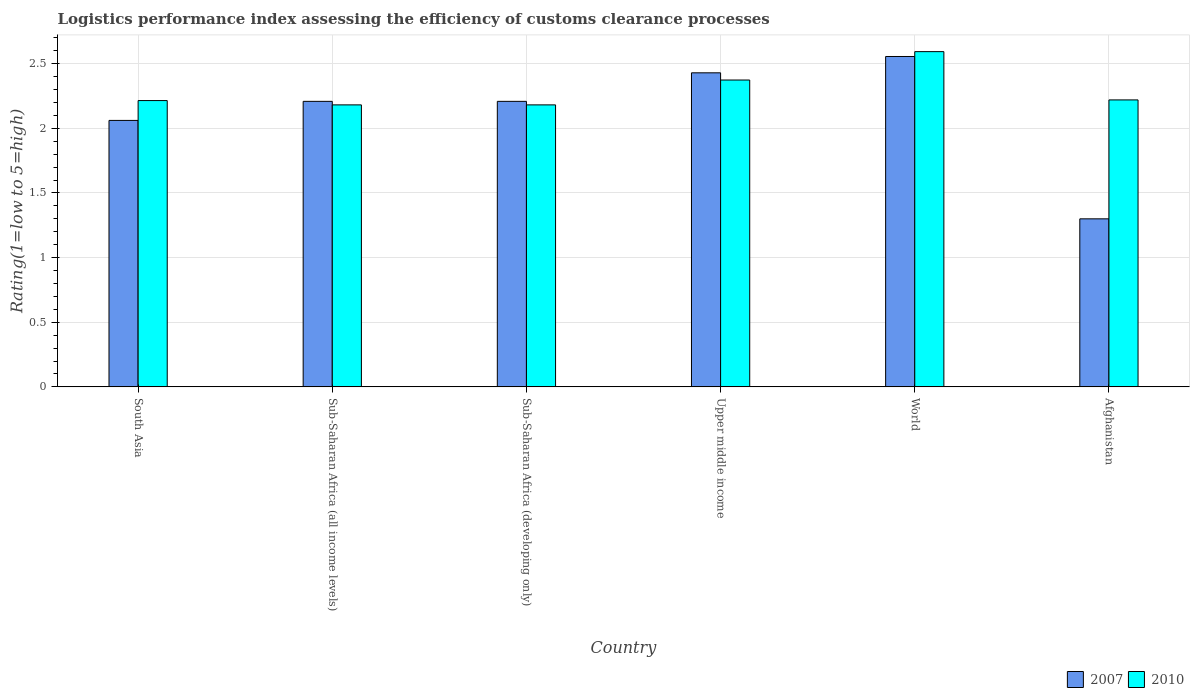Are the number of bars on each tick of the X-axis equal?
Your answer should be compact. Yes. How many bars are there on the 6th tick from the left?
Your answer should be compact. 2. How many bars are there on the 3rd tick from the right?
Make the answer very short. 2. What is the label of the 3rd group of bars from the left?
Provide a short and direct response. Sub-Saharan Africa (developing only). What is the Logistic performance index in 2010 in Sub-Saharan Africa (developing only)?
Your response must be concise. 2.18. Across all countries, what is the maximum Logistic performance index in 2010?
Make the answer very short. 2.59. Across all countries, what is the minimum Logistic performance index in 2010?
Make the answer very short. 2.18. In which country was the Logistic performance index in 2010 minimum?
Your answer should be very brief. Sub-Saharan Africa (all income levels). What is the total Logistic performance index in 2007 in the graph?
Provide a short and direct response. 12.77. What is the difference between the Logistic performance index in 2007 in Sub-Saharan Africa (developing only) and that in World?
Offer a very short reply. -0.35. What is the difference between the Logistic performance index in 2010 in Upper middle income and the Logistic performance index in 2007 in World?
Make the answer very short. -0.18. What is the average Logistic performance index in 2007 per country?
Your answer should be compact. 2.13. What is the difference between the Logistic performance index of/in 2007 and Logistic performance index of/in 2010 in World?
Your answer should be very brief. -0.04. In how many countries, is the Logistic performance index in 2007 greater than 0.9?
Keep it short and to the point. 6. What is the ratio of the Logistic performance index in 2010 in South Asia to that in Upper middle income?
Provide a short and direct response. 0.93. Is the difference between the Logistic performance index in 2007 in South Asia and World greater than the difference between the Logistic performance index in 2010 in South Asia and World?
Your answer should be compact. No. What is the difference between the highest and the second highest Logistic performance index in 2007?
Provide a short and direct response. -0.35. What is the difference between the highest and the lowest Logistic performance index in 2010?
Your response must be concise. 0.41. What does the 1st bar from the right in Sub-Saharan Africa (developing only) represents?
Your response must be concise. 2010. Are all the bars in the graph horizontal?
Your answer should be very brief. No. How many legend labels are there?
Keep it short and to the point. 2. How are the legend labels stacked?
Offer a terse response. Horizontal. What is the title of the graph?
Ensure brevity in your answer.  Logistics performance index assessing the efficiency of customs clearance processes. Does "1983" appear as one of the legend labels in the graph?
Give a very brief answer. No. What is the label or title of the Y-axis?
Your answer should be very brief. Rating(1=low to 5=high). What is the Rating(1=low to 5=high) of 2007 in South Asia?
Make the answer very short. 2.06. What is the Rating(1=low to 5=high) of 2010 in South Asia?
Make the answer very short. 2.21. What is the Rating(1=low to 5=high) of 2007 in Sub-Saharan Africa (all income levels)?
Your response must be concise. 2.21. What is the Rating(1=low to 5=high) in 2010 in Sub-Saharan Africa (all income levels)?
Make the answer very short. 2.18. What is the Rating(1=low to 5=high) of 2007 in Sub-Saharan Africa (developing only)?
Your response must be concise. 2.21. What is the Rating(1=low to 5=high) of 2010 in Sub-Saharan Africa (developing only)?
Offer a very short reply. 2.18. What is the Rating(1=low to 5=high) of 2007 in Upper middle income?
Make the answer very short. 2.43. What is the Rating(1=low to 5=high) in 2010 in Upper middle income?
Ensure brevity in your answer.  2.37. What is the Rating(1=low to 5=high) of 2007 in World?
Provide a succinct answer. 2.56. What is the Rating(1=low to 5=high) in 2010 in World?
Offer a very short reply. 2.59. What is the Rating(1=low to 5=high) in 2010 in Afghanistan?
Make the answer very short. 2.22. Across all countries, what is the maximum Rating(1=low to 5=high) of 2007?
Offer a very short reply. 2.56. Across all countries, what is the maximum Rating(1=low to 5=high) in 2010?
Your answer should be very brief. 2.59. Across all countries, what is the minimum Rating(1=low to 5=high) in 2007?
Offer a very short reply. 1.3. Across all countries, what is the minimum Rating(1=low to 5=high) of 2010?
Your answer should be very brief. 2.18. What is the total Rating(1=low to 5=high) of 2007 in the graph?
Keep it short and to the point. 12.77. What is the total Rating(1=low to 5=high) in 2010 in the graph?
Your response must be concise. 13.77. What is the difference between the Rating(1=low to 5=high) of 2007 in South Asia and that in Sub-Saharan Africa (all income levels)?
Your answer should be compact. -0.15. What is the difference between the Rating(1=low to 5=high) in 2007 in South Asia and that in Sub-Saharan Africa (developing only)?
Ensure brevity in your answer.  -0.15. What is the difference between the Rating(1=low to 5=high) of 2007 in South Asia and that in Upper middle income?
Make the answer very short. -0.37. What is the difference between the Rating(1=low to 5=high) of 2010 in South Asia and that in Upper middle income?
Your response must be concise. -0.16. What is the difference between the Rating(1=low to 5=high) of 2007 in South Asia and that in World?
Offer a terse response. -0.49. What is the difference between the Rating(1=low to 5=high) of 2010 in South Asia and that in World?
Make the answer very short. -0.38. What is the difference between the Rating(1=low to 5=high) of 2007 in South Asia and that in Afghanistan?
Your answer should be compact. 0.76. What is the difference between the Rating(1=low to 5=high) in 2010 in South Asia and that in Afghanistan?
Offer a very short reply. -0.01. What is the difference between the Rating(1=low to 5=high) of 2010 in Sub-Saharan Africa (all income levels) and that in Sub-Saharan Africa (developing only)?
Offer a very short reply. 0. What is the difference between the Rating(1=low to 5=high) in 2007 in Sub-Saharan Africa (all income levels) and that in Upper middle income?
Make the answer very short. -0.22. What is the difference between the Rating(1=low to 5=high) in 2010 in Sub-Saharan Africa (all income levels) and that in Upper middle income?
Your answer should be very brief. -0.19. What is the difference between the Rating(1=low to 5=high) in 2007 in Sub-Saharan Africa (all income levels) and that in World?
Your response must be concise. -0.35. What is the difference between the Rating(1=low to 5=high) of 2010 in Sub-Saharan Africa (all income levels) and that in World?
Provide a short and direct response. -0.41. What is the difference between the Rating(1=low to 5=high) of 2007 in Sub-Saharan Africa (all income levels) and that in Afghanistan?
Your answer should be very brief. 0.91. What is the difference between the Rating(1=low to 5=high) of 2010 in Sub-Saharan Africa (all income levels) and that in Afghanistan?
Provide a succinct answer. -0.04. What is the difference between the Rating(1=low to 5=high) of 2007 in Sub-Saharan Africa (developing only) and that in Upper middle income?
Give a very brief answer. -0.22. What is the difference between the Rating(1=low to 5=high) of 2010 in Sub-Saharan Africa (developing only) and that in Upper middle income?
Offer a terse response. -0.19. What is the difference between the Rating(1=low to 5=high) in 2007 in Sub-Saharan Africa (developing only) and that in World?
Your answer should be very brief. -0.35. What is the difference between the Rating(1=low to 5=high) of 2010 in Sub-Saharan Africa (developing only) and that in World?
Your response must be concise. -0.41. What is the difference between the Rating(1=low to 5=high) in 2007 in Sub-Saharan Africa (developing only) and that in Afghanistan?
Ensure brevity in your answer.  0.91. What is the difference between the Rating(1=low to 5=high) of 2010 in Sub-Saharan Africa (developing only) and that in Afghanistan?
Keep it short and to the point. -0.04. What is the difference between the Rating(1=low to 5=high) in 2007 in Upper middle income and that in World?
Provide a succinct answer. -0.13. What is the difference between the Rating(1=low to 5=high) of 2010 in Upper middle income and that in World?
Provide a succinct answer. -0.22. What is the difference between the Rating(1=low to 5=high) of 2007 in Upper middle income and that in Afghanistan?
Ensure brevity in your answer.  1.13. What is the difference between the Rating(1=low to 5=high) of 2010 in Upper middle income and that in Afghanistan?
Ensure brevity in your answer.  0.15. What is the difference between the Rating(1=low to 5=high) in 2007 in World and that in Afghanistan?
Provide a short and direct response. 1.26. What is the difference between the Rating(1=low to 5=high) of 2010 in World and that in Afghanistan?
Provide a succinct answer. 0.37. What is the difference between the Rating(1=low to 5=high) of 2007 in South Asia and the Rating(1=low to 5=high) of 2010 in Sub-Saharan Africa (all income levels)?
Provide a succinct answer. -0.12. What is the difference between the Rating(1=low to 5=high) of 2007 in South Asia and the Rating(1=low to 5=high) of 2010 in Sub-Saharan Africa (developing only)?
Keep it short and to the point. -0.12. What is the difference between the Rating(1=low to 5=high) of 2007 in South Asia and the Rating(1=low to 5=high) of 2010 in Upper middle income?
Ensure brevity in your answer.  -0.31. What is the difference between the Rating(1=low to 5=high) in 2007 in South Asia and the Rating(1=low to 5=high) in 2010 in World?
Your answer should be compact. -0.53. What is the difference between the Rating(1=low to 5=high) of 2007 in South Asia and the Rating(1=low to 5=high) of 2010 in Afghanistan?
Provide a short and direct response. -0.16. What is the difference between the Rating(1=low to 5=high) of 2007 in Sub-Saharan Africa (all income levels) and the Rating(1=low to 5=high) of 2010 in Sub-Saharan Africa (developing only)?
Provide a short and direct response. 0.03. What is the difference between the Rating(1=low to 5=high) in 2007 in Sub-Saharan Africa (all income levels) and the Rating(1=low to 5=high) in 2010 in Upper middle income?
Provide a short and direct response. -0.16. What is the difference between the Rating(1=low to 5=high) in 2007 in Sub-Saharan Africa (all income levels) and the Rating(1=low to 5=high) in 2010 in World?
Your answer should be compact. -0.38. What is the difference between the Rating(1=low to 5=high) in 2007 in Sub-Saharan Africa (all income levels) and the Rating(1=low to 5=high) in 2010 in Afghanistan?
Make the answer very short. -0.01. What is the difference between the Rating(1=low to 5=high) in 2007 in Sub-Saharan Africa (developing only) and the Rating(1=low to 5=high) in 2010 in Upper middle income?
Your answer should be compact. -0.16. What is the difference between the Rating(1=low to 5=high) of 2007 in Sub-Saharan Africa (developing only) and the Rating(1=low to 5=high) of 2010 in World?
Provide a succinct answer. -0.38. What is the difference between the Rating(1=low to 5=high) of 2007 in Sub-Saharan Africa (developing only) and the Rating(1=low to 5=high) of 2010 in Afghanistan?
Your response must be concise. -0.01. What is the difference between the Rating(1=low to 5=high) in 2007 in Upper middle income and the Rating(1=low to 5=high) in 2010 in World?
Provide a short and direct response. -0.16. What is the difference between the Rating(1=low to 5=high) of 2007 in Upper middle income and the Rating(1=low to 5=high) of 2010 in Afghanistan?
Offer a terse response. 0.21. What is the difference between the Rating(1=low to 5=high) in 2007 in World and the Rating(1=low to 5=high) in 2010 in Afghanistan?
Offer a very short reply. 0.34. What is the average Rating(1=low to 5=high) in 2007 per country?
Give a very brief answer. 2.13. What is the average Rating(1=low to 5=high) of 2010 per country?
Make the answer very short. 2.29. What is the difference between the Rating(1=low to 5=high) in 2007 and Rating(1=low to 5=high) in 2010 in South Asia?
Provide a succinct answer. -0.15. What is the difference between the Rating(1=low to 5=high) of 2007 and Rating(1=low to 5=high) of 2010 in Sub-Saharan Africa (all income levels)?
Your response must be concise. 0.03. What is the difference between the Rating(1=low to 5=high) of 2007 and Rating(1=low to 5=high) of 2010 in Sub-Saharan Africa (developing only)?
Make the answer very short. 0.03. What is the difference between the Rating(1=low to 5=high) of 2007 and Rating(1=low to 5=high) of 2010 in Upper middle income?
Provide a short and direct response. 0.06. What is the difference between the Rating(1=low to 5=high) of 2007 and Rating(1=low to 5=high) of 2010 in World?
Make the answer very short. -0.04. What is the difference between the Rating(1=low to 5=high) of 2007 and Rating(1=low to 5=high) of 2010 in Afghanistan?
Make the answer very short. -0.92. What is the ratio of the Rating(1=low to 5=high) in 2007 in South Asia to that in Sub-Saharan Africa (all income levels)?
Offer a terse response. 0.93. What is the ratio of the Rating(1=low to 5=high) in 2010 in South Asia to that in Sub-Saharan Africa (all income levels)?
Ensure brevity in your answer.  1.02. What is the ratio of the Rating(1=low to 5=high) in 2007 in South Asia to that in Sub-Saharan Africa (developing only)?
Give a very brief answer. 0.93. What is the ratio of the Rating(1=low to 5=high) in 2010 in South Asia to that in Sub-Saharan Africa (developing only)?
Provide a succinct answer. 1.02. What is the ratio of the Rating(1=low to 5=high) of 2007 in South Asia to that in Upper middle income?
Provide a succinct answer. 0.85. What is the ratio of the Rating(1=low to 5=high) in 2010 in South Asia to that in Upper middle income?
Your answer should be compact. 0.93. What is the ratio of the Rating(1=low to 5=high) in 2007 in South Asia to that in World?
Provide a succinct answer. 0.81. What is the ratio of the Rating(1=low to 5=high) in 2010 in South Asia to that in World?
Provide a succinct answer. 0.85. What is the ratio of the Rating(1=low to 5=high) of 2007 in South Asia to that in Afghanistan?
Your answer should be very brief. 1.59. What is the ratio of the Rating(1=low to 5=high) of 2010 in South Asia to that in Afghanistan?
Make the answer very short. 1. What is the ratio of the Rating(1=low to 5=high) of 2007 in Sub-Saharan Africa (all income levels) to that in Sub-Saharan Africa (developing only)?
Your answer should be very brief. 1. What is the ratio of the Rating(1=low to 5=high) in 2007 in Sub-Saharan Africa (all income levels) to that in Upper middle income?
Give a very brief answer. 0.91. What is the ratio of the Rating(1=low to 5=high) of 2010 in Sub-Saharan Africa (all income levels) to that in Upper middle income?
Offer a very short reply. 0.92. What is the ratio of the Rating(1=low to 5=high) in 2007 in Sub-Saharan Africa (all income levels) to that in World?
Offer a terse response. 0.86. What is the ratio of the Rating(1=low to 5=high) of 2010 in Sub-Saharan Africa (all income levels) to that in World?
Provide a short and direct response. 0.84. What is the ratio of the Rating(1=low to 5=high) in 2007 in Sub-Saharan Africa (all income levels) to that in Afghanistan?
Offer a very short reply. 1.7. What is the ratio of the Rating(1=low to 5=high) in 2010 in Sub-Saharan Africa (all income levels) to that in Afghanistan?
Ensure brevity in your answer.  0.98. What is the ratio of the Rating(1=low to 5=high) in 2007 in Sub-Saharan Africa (developing only) to that in Upper middle income?
Your response must be concise. 0.91. What is the ratio of the Rating(1=low to 5=high) in 2010 in Sub-Saharan Africa (developing only) to that in Upper middle income?
Keep it short and to the point. 0.92. What is the ratio of the Rating(1=low to 5=high) in 2007 in Sub-Saharan Africa (developing only) to that in World?
Make the answer very short. 0.86. What is the ratio of the Rating(1=low to 5=high) of 2010 in Sub-Saharan Africa (developing only) to that in World?
Ensure brevity in your answer.  0.84. What is the ratio of the Rating(1=low to 5=high) of 2007 in Sub-Saharan Africa (developing only) to that in Afghanistan?
Ensure brevity in your answer.  1.7. What is the ratio of the Rating(1=low to 5=high) in 2010 in Sub-Saharan Africa (developing only) to that in Afghanistan?
Ensure brevity in your answer.  0.98. What is the ratio of the Rating(1=low to 5=high) in 2007 in Upper middle income to that in World?
Your answer should be compact. 0.95. What is the ratio of the Rating(1=low to 5=high) in 2010 in Upper middle income to that in World?
Provide a short and direct response. 0.92. What is the ratio of the Rating(1=low to 5=high) of 2007 in Upper middle income to that in Afghanistan?
Ensure brevity in your answer.  1.87. What is the ratio of the Rating(1=low to 5=high) of 2010 in Upper middle income to that in Afghanistan?
Give a very brief answer. 1.07. What is the ratio of the Rating(1=low to 5=high) in 2007 in World to that in Afghanistan?
Make the answer very short. 1.97. What is the ratio of the Rating(1=low to 5=high) in 2010 in World to that in Afghanistan?
Make the answer very short. 1.17. What is the difference between the highest and the second highest Rating(1=low to 5=high) of 2007?
Make the answer very short. 0.13. What is the difference between the highest and the second highest Rating(1=low to 5=high) in 2010?
Your response must be concise. 0.22. What is the difference between the highest and the lowest Rating(1=low to 5=high) in 2007?
Ensure brevity in your answer.  1.26. What is the difference between the highest and the lowest Rating(1=low to 5=high) of 2010?
Make the answer very short. 0.41. 